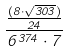<formula> <loc_0><loc_0><loc_500><loc_500>\frac { \frac { ( 8 \cdot \sqrt { 3 0 3 } ) } { 2 4 } } { 6 ^ { 3 7 4 } \cdot 7 }</formula> 